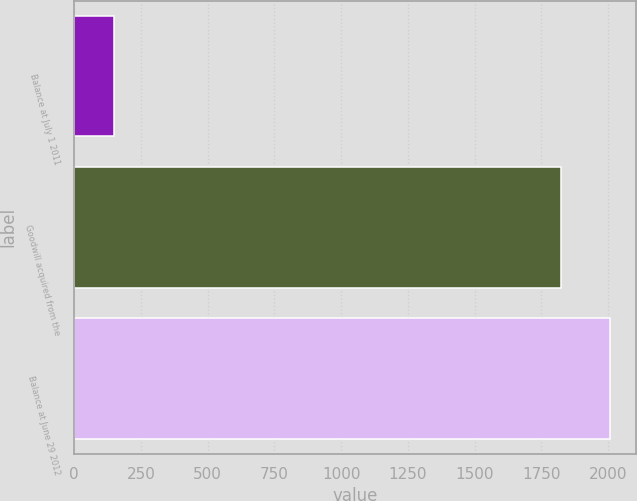Convert chart to OTSL. <chart><loc_0><loc_0><loc_500><loc_500><bar_chart><fcel>Balance at July 1 2011<fcel>Goodwill acquired from the<fcel>Balance at June 29 2012<nl><fcel>151<fcel>1824<fcel>2006.4<nl></chart> 